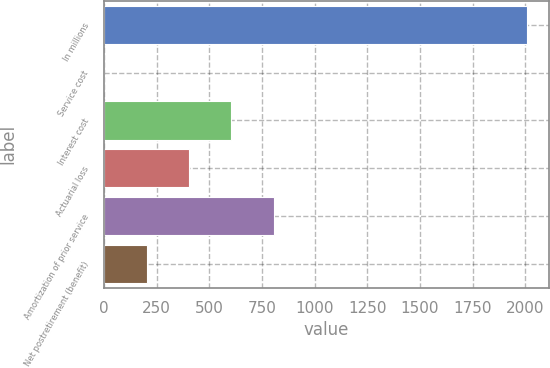Convert chart. <chart><loc_0><loc_0><loc_500><loc_500><bar_chart><fcel>In millions<fcel>Service cost<fcel>Interest cost<fcel>Actuarial loss<fcel>Amortization of prior service<fcel>Net postretirement (benefit)<nl><fcel>2011<fcel>2<fcel>604.7<fcel>403.8<fcel>805.6<fcel>202.9<nl></chart> 